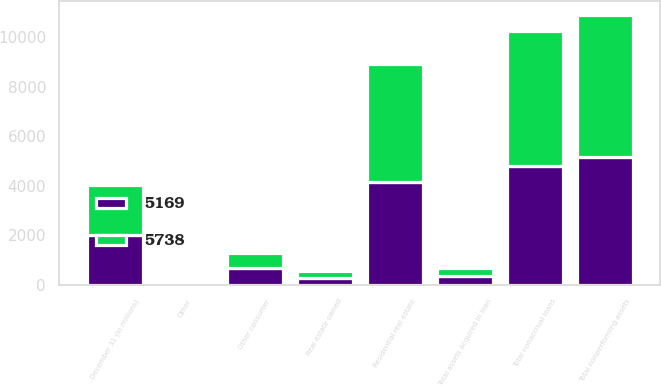Convert chart to OTSL. <chart><loc_0><loc_0><loc_500><loc_500><stacked_bar_chart><ecel><fcel>December 31 (in millions)<fcel>Residential real estate<fcel>Other consumer<fcel>Total nonaccrual loans<fcel>Real estate owned<fcel>Other<fcel>Total assets acquired in loan<fcel>Total nonperforming assets<nl><fcel>5169<fcel>2016<fcel>4145<fcel>675<fcel>4820<fcel>292<fcel>57<fcel>349<fcel>5169<nl><fcel>5738<fcel>2015<fcel>4792<fcel>621<fcel>5413<fcel>277<fcel>48<fcel>325<fcel>5738<nl></chart> 